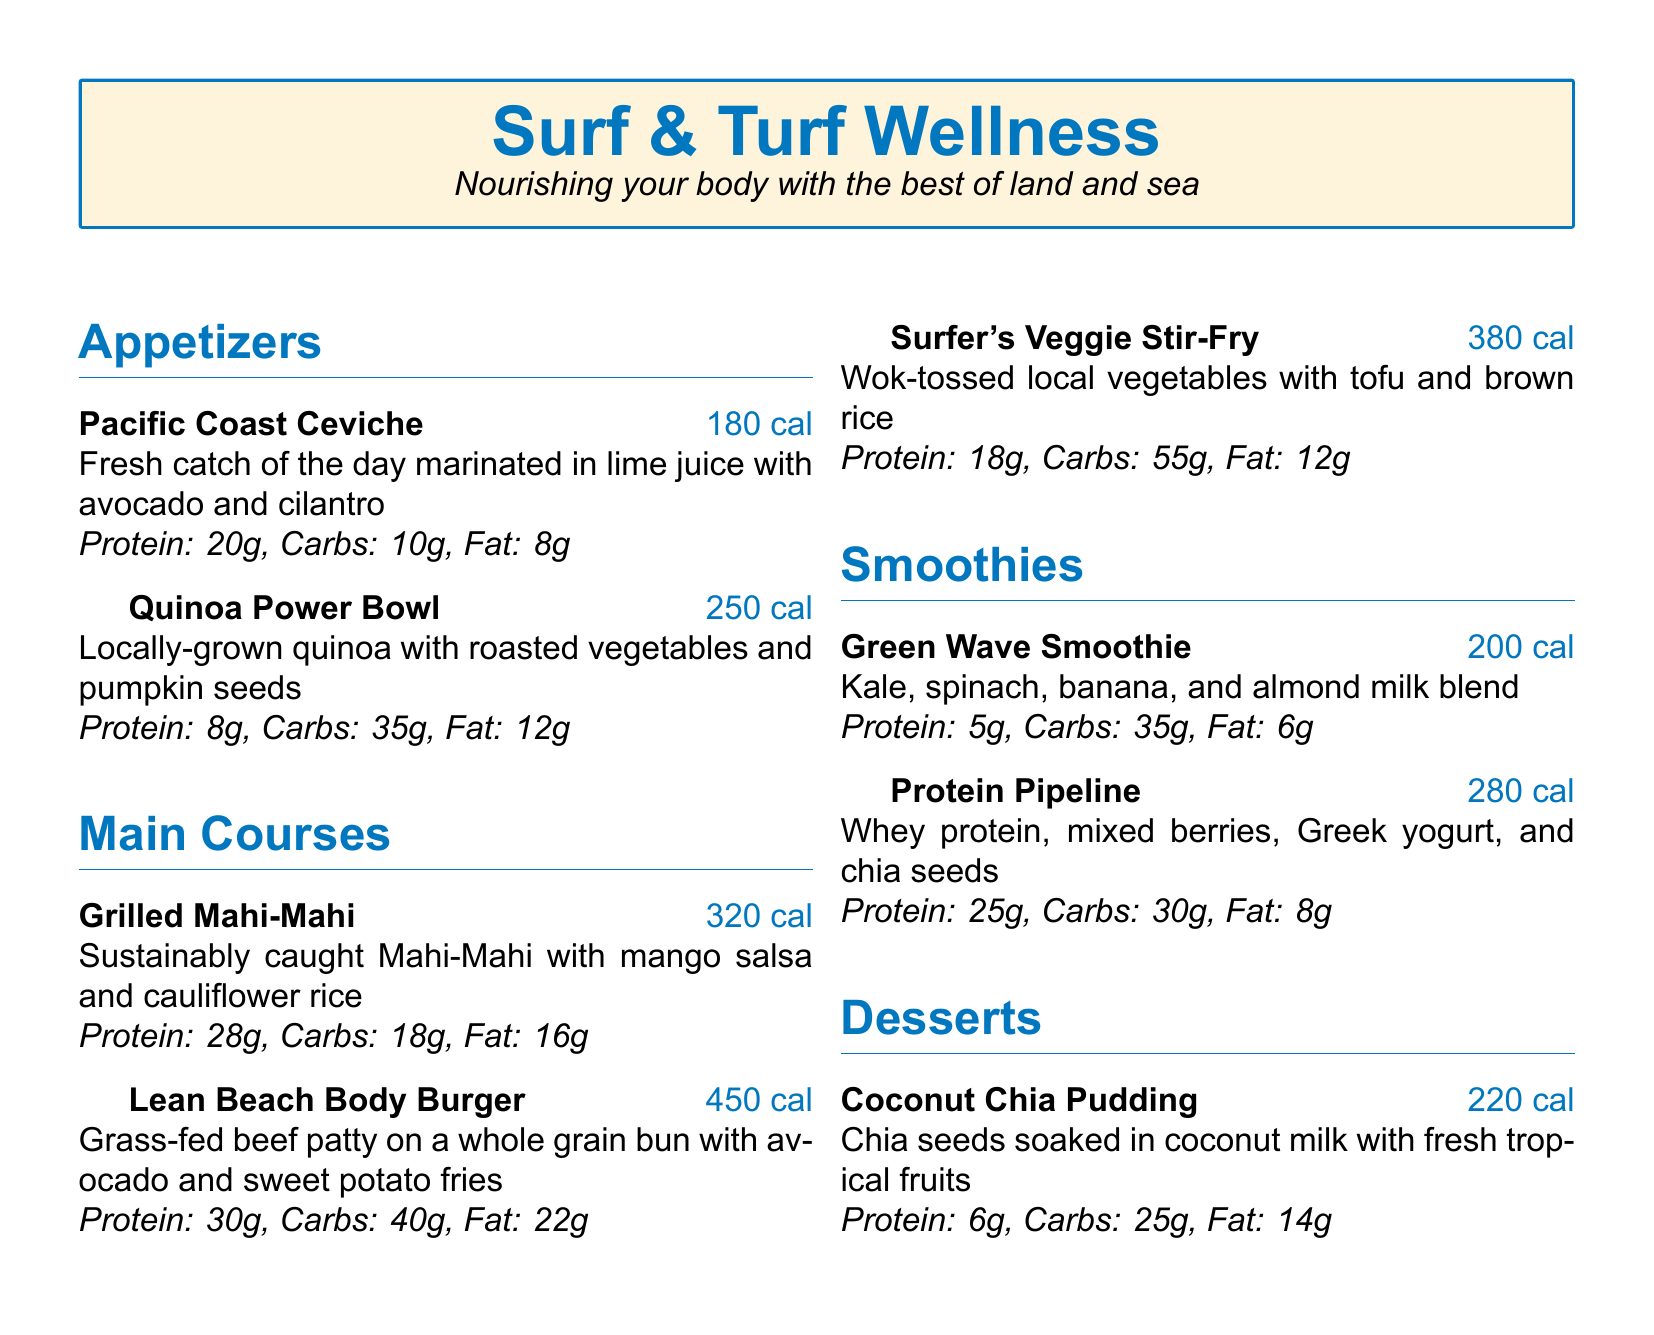What is the calorie count of the Pacific Coast Ceviche? The Pacific Coast Ceviche has a designated calorie amount listed in the document, which is 180 cal.
Answer: 180 cal What ingredients are in the Quinoa Power Bowl? The ingredients of the Quinoa Power Bowl are specified as locally-grown quinoa with roasted vegetables and pumpkin seeds.
Answer: Locally-grown quinoa, roasted vegetables, pumpkin seeds How many grams of protein are in the Grilled Mahi-Mahi? The document explicitly states that the Grilled Mahi-Mahi contains 28 grams of protein.
Answer: 28g What is the total calorie count of all appetizers? To find the total calorie count of all appetizers, add the calories of Pacific Coast Ceviche and Quinoa Power Bowl: 180 + 250 = 430.
Answer: 430 cal Which dessert has the highest fat content? The document lists the fat content for each dessert, and Coconut Chia Pudding has 14 grams, which is the highest.
Answer: Coconut Chia Pudding What is the main protein source in the Protein Pipeline smoothie? The main protein source in the Protein Pipeline smoothie is whey protein, as indicated in the ingredients.
Answer: Whey protein What type of burger is featured in the Main Courses section? The type of burger highlighted in the Main Courses section is a Lean Beach Body Burger.
Answer: Lean Beach Body Burger How many grams of carbohydrates are in the Surfer's Veggie Stir-Fry? The document specifies that the Surfer's Veggie Stir-Fry contains 55 grams of carbohydrates.
Answer: 55g 